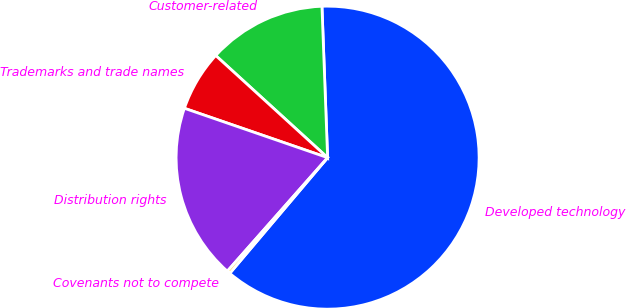Convert chart. <chart><loc_0><loc_0><loc_500><loc_500><pie_chart><fcel>Developed technology<fcel>Customer-related<fcel>Trademarks and trade names<fcel>Distribution rights<fcel>Covenants not to compete<nl><fcel>61.77%<fcel>12.63%<fcel>6.49%<fcel>18.77%<fcel>0.34%<nl></chart> 